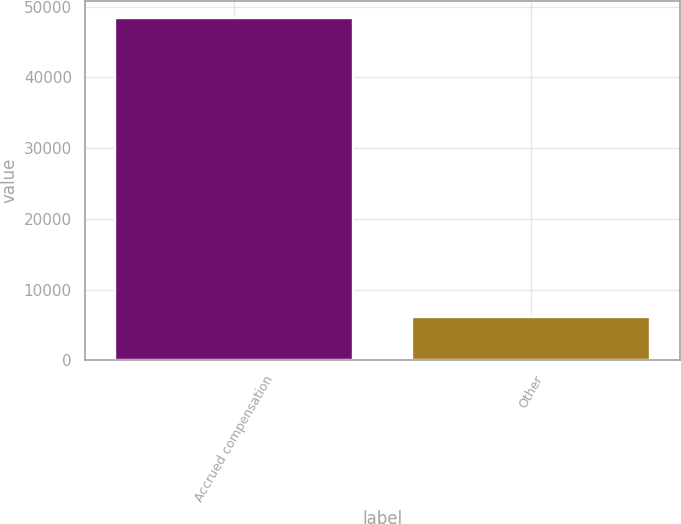Convert chart to OTSL. <chart><loc_0><loc_0><loc_500><loc_500><bar_chart><fcel>Accrued compensation<fcel>Other<nl><fcel>48444<fcel>6163<nl></chart> 